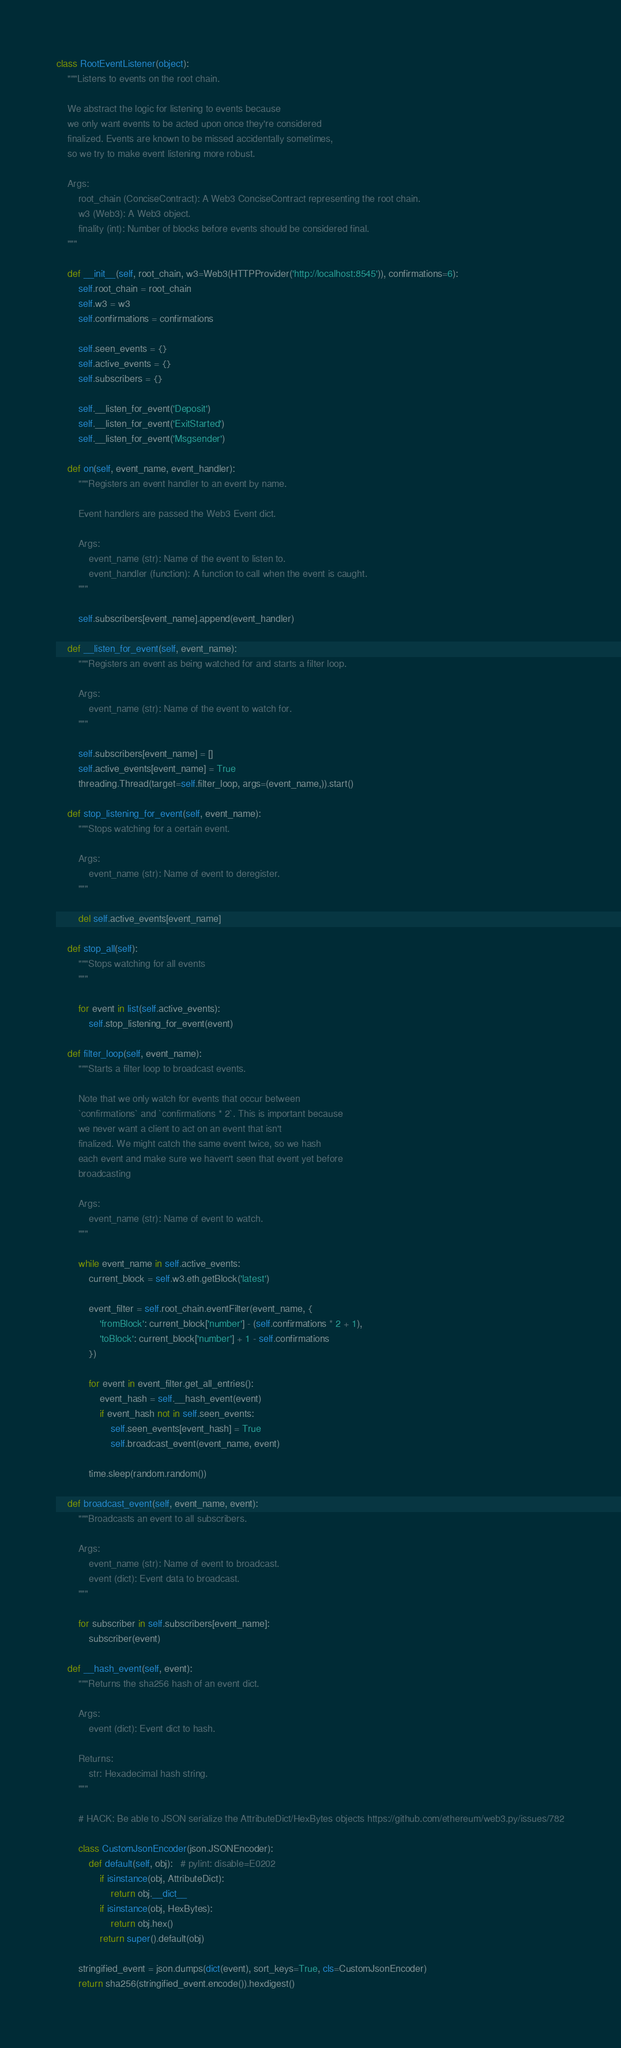<code> <loc_0><loc_0><loc_500><loc_500><_Python_>class RootEventListener(object):
    """Listens to events on the root chain.

    We abstract the logic for listening to events because
    we only want events to be acted upon once they're considered
    finalized. Events are known to be missed accidentally sometimes,
    so we try to make event listening more robust.

    Args:
        root_chain (ConciseContract): A Web3 ConciseContract representing the root chain.
        w3 (Web3): A Web3 object.
        finality (int): Number of blocks before events should be considered final.
    """

    def __init__(self, root_chain, w3=Web3(HTTPProvider('http://localhost:8545')), confirmations=6):
        self.root_chain = root_chain
        self.w3 = w3
        self.confirmations = confirmations

        self.seen_events = {}
        self.active_events = {}
        self.subscribers = {}

        self.__listen_for_event('Deposit')
        self.__listen_for_event('ExitStarted')
        self.__listen_for_event('Msgsender')

    def on(self, event_name, event_handler):
        """Registers an event handler to an event by name.

        Event handlers are passed the Web3 Event dict.

        Args:
            event_name (str): Name of the event to listen to.
            event_handler (function): A function to call when the event is caught.
        """

        self.subscribers[event_name].append(event_handler)

    def __listen_for_event(self, event_name):
        """Registers an event as being watched for and starts a filter loop.

        Args:
            event_name (str): Name of the event to watch for.
        """

        self.subscribers[event_name] = []
        self.active_events[event_name] = True
        threading.Thread(target=self.filter_loop, args=(event_name,)).start()

    def stop_listening_for_event(self, event_name):
        """Stops watching for a certain event.

        Args:
            event_name (str): Name of event to deregister.
        """

        del self.active_events[event_name]

    def stop_all(self):
        """Stops watching for all events
        """

        for event in list(self.active_events):
            self.stop_listening_for_event(event)

    def filter_loop(self, event_name):
        """Starts a filter loop to broadcast events.

        Note that we only watch for events that occur between
        `confirmations` and `confirmations * 2`. This is important because
        we never want a client to act on an event that isn't
        finalized. We might catch the same event twice, so we hash
        each event and make sure we haven't seen that event yet before
        broadcasting

        Args:
            event_name (str): Name of event to watch.
        """

        while event_name in self.active_events:
            current_block = self.w3.eth.getBlock('latest')

            event_filter = self.root_chain.eventFilter(event_name, {
                'fromBlock': current_block['number'] - (self.confirmations * 2 + 1),
                'toBlock': current_block['number'] + 1 - self.confirmations
            })

            for event in event_filter.get_all_entries():
                event_hash = self.__hash_event(event)
                if event_hash not in self.seen_events:
                    self.seen_events[event_hash] = True
                    self.broadcast_event(event_name, event)

            time.sleep(random.random())

    def broadcast_event(self, event_name, event):
        """Broadcasts an event to all subscribers.

        Args:
            event_name (str): Name of event to broadcast.
            event (dict): Event data to broadcast.
        """

        for subscriber in self.subscribers[event_name]:
            subscriber(event)

    def __hash_event(self, event):
        """Returns the sha256 hash of an event dict.

        Args:
            event (dict): Event dict to hash.

        Returns:
            str: Hexadecimal hash string.
        """

        # HACK: Be able to JSON serialize the AttributeDict/HexBytes objects https://github.com/ethereum/web3.py/issues/782

        class CustomJsonEncoder(json.JSONEncoder):
            def default(self, obj):   # pylint: disable=E0202
                if isinstance(obj, AttributeDict):
                    return obj.__dict__
                if isinstance(obj, HexBytes):
                    return obj.hex()
                return super().default(obj)

        stringified_event = json.dumps(dict(event), sort_keys=True, cls=CustomJsonEncoder)
        return sha256(stringified_event.encode()).hexdigest()
</code> 